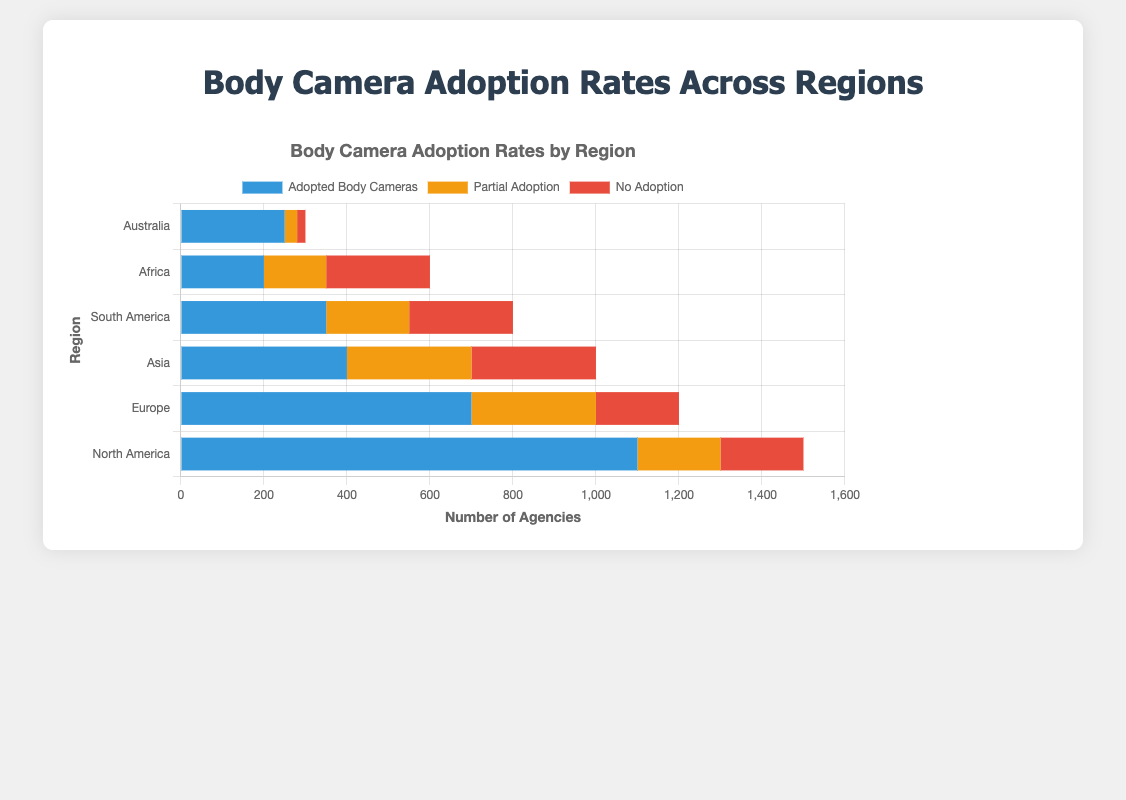Which region has the highest number of agencies with adopted body cameras? The bar labeled "North America" has the longest section in blue, representing the number of agencies with adopted body cameras, making it the highest.
Answer: North America Which region has the lowest number of agencies with partial adoption of body cameras? The bar labeled "Australia" has the shortest section in yellow, representing the number of agencies with partial adoption of body cameras, making it the lowest.
Answer: Australia What is the total number of law enforcement agencies in Europe? According to the chart, the total height of the "Europe" bar is composed of three segments which represent adopted body cameras (700), partial adoption (300), and no adoption (200). Summing these values gives the total number of agencies.
Answer: 1200 Compare the number of agencies with no adoption of body cameras between Asia and South America. Which region has more? The red sections of the "Asia" and "South America" bars represent the agencies with no adoption. For Asia, the count is 300, while for South America, it is 250. Therefore, Asia has more.
Answer: Asia What is the combined total number of agencies with either partial or no adoption in Africa? The yellow section (partial adoption) is 150, and the red section (no adoption) is 250. Summing these values provides the total number of agencies with either partial or no adoption.
Answer: 400 Which region has the closest number of agencies with adopted body cameras to Europe? Both the "Asia" and "South America" bars have significant blue sections representing the number of agencies with adopted body cameras. Comparing visually, South America's total of 350 adopted agencies is closer to Europe's 700 than Asia's 400.
Answer: South America How many more agencies in North America have adopted body cameras compared to Africa? The blue section in North America represents 1100 agencies, while the blue section in Africa shows 200 agencies. Subtracting these gives the difference.
Answer: 900 What is the percentage of agencies with adopted body cameras in Australia? The blue section for Australia represents 250 agencies out of a total of 300 agencies. The percentage is calculated as (250/300) * 100.
Answer: Approximately 83.33% How does the number of agencies with partial adoption in Europe compare to those in North America? The yellow sections in Europe and North America represent partial adoptions. Europe has 300 agencies with partial adoption, while North America has 200. Therefore, Europe has more.
Answer: Europe Which region has the smallest total number of agencies, and what is that number? Looking at the total lengths of the bars, Australia has the shortest bar representing a total number of agencies. Summing the segments for Australia gives 250 (adopted) + 30 (partial) + 20 (no adoption).
Answer: 300 